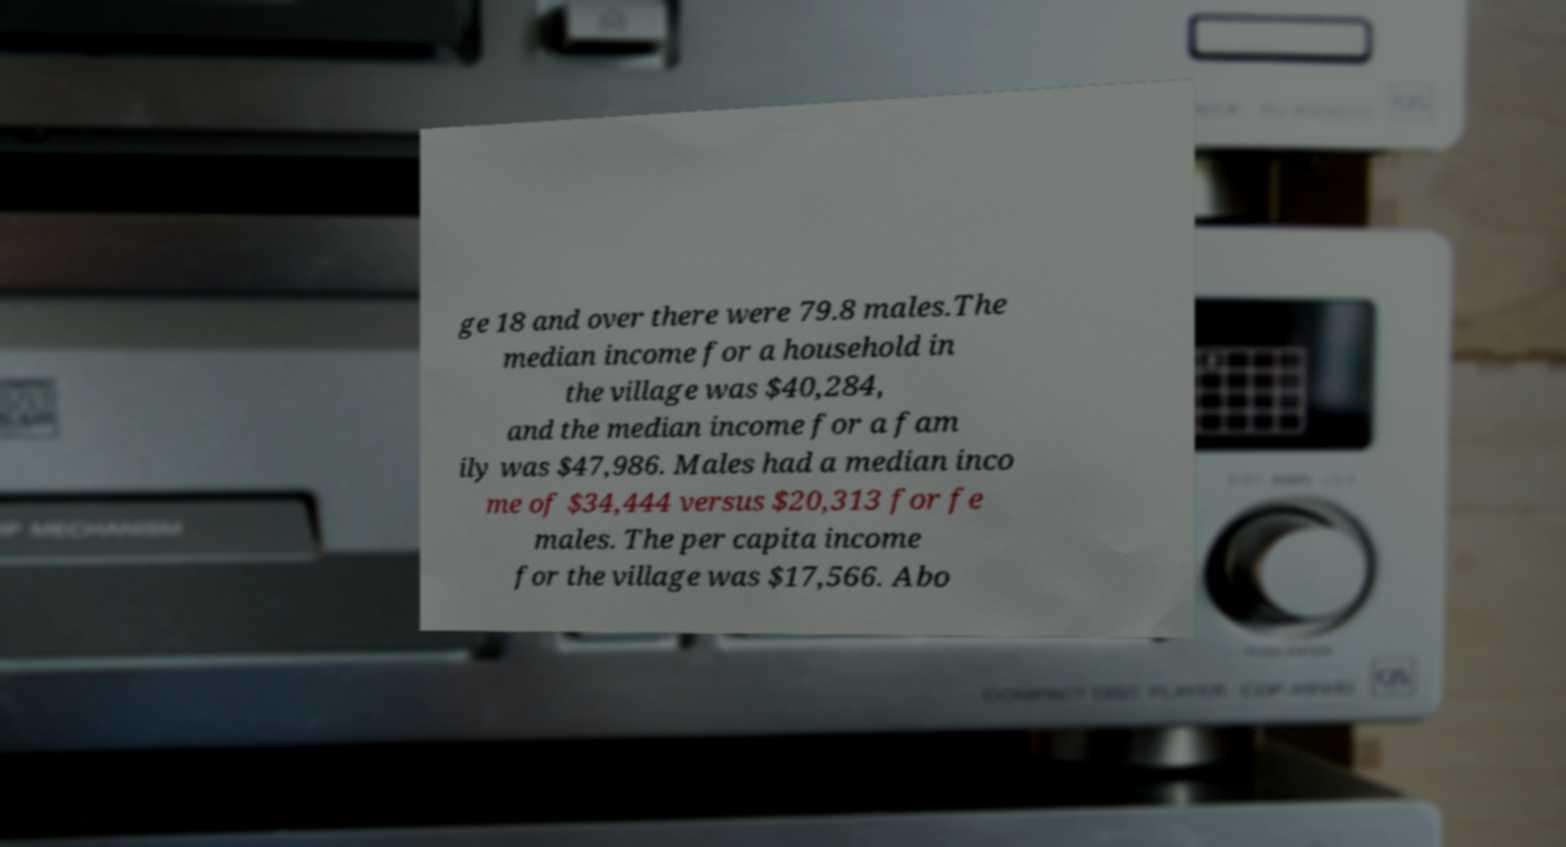Please read and relay the text visible in this image. What does it say? ge 18 and over there were 79.8 males.The median income for a household in the village was $40,284, and the median income for a fam ily was $47,986. Males had a median inco me of $34,444 versus $20,313 for fe males. The per capita income for the village was $17,566. Abo 